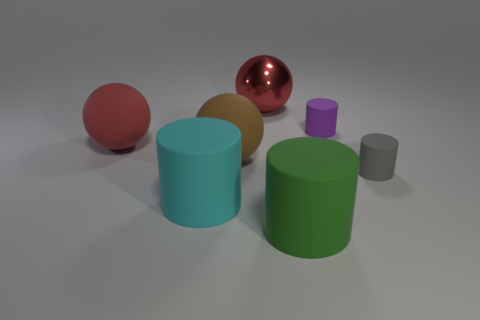The other tiny object that is the same shape as the tiny purple matte object is what color?
Your answer should be very brief. Gray. There is a big metal sphere; is it the same color as the tiny cylinder in front of the purple object?
Offer a terse response. No. What shape is the matte thing that is both on the right side of the green cylinder and in front of the purple matte object?
Offer a very short reply. Cylinder. Are there fewer shiny objects than small cylinders?
Ensure brevity in your answer.  Yes. Are there any tiny cylinders?
Your response must be concise. Yes. What number of other objects are the same size as the purple cylinder?
Keep it short and to the point. 1. Do the gray cylinder and the cyan object on the left side of the gray rubber cylinder have the same material?
Offer a very short reply. Yes. Is the number of large rubber balls that are on the left side of the cyan cylinder the same as the number of gray rubber cylinders that are on the right side of the gray object?
Ensure brevity in your answer.  No. What is the green cylinder made of?
Your answer should be compact. Rubber. There is a shiny thing that is the same size as the green cylinder; what color is it?
Your response must be concise. Red. 